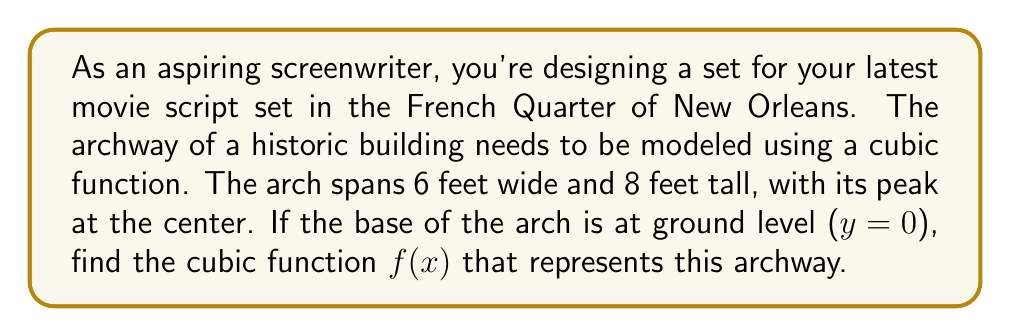Provide a solution to this math problem. Let's approach this step-by-step:

1) The general form of a cubic function is:
   $$f(x) = ax^3 + bx^2 + cx + d$$

2) We know the following points about the arch:
   - It starts at (0, 0)
   - It ends at (6, 0)
   - Its peak is at (3, 8)

3) Let's use these points to set up equations:
   - (0, 0): $f(0) = d = 0$
   - (6, 0): $f(6) = 216a + 36b + 6c + d = 0$
   - (3, 8): $f(3) = 27a + 9b + 3c + d = 8$

4) Since $d = 0$, our function simplifies to:
   $$f(x) = ax^3 + bx^2 + cx$$

5) Now we have two equations:
   $216a + 36b + 6c = 0$  (1)
   $27a + 9b + 3c = 8$    (2)

6) We need one more equation. We can use the fact that the derivative of $f(x)$ at x = 3 should be zero (since it's the peak):
   $$f'(x) = 3ax^2 + 2bx + c$$
   $$f'(3) = 27a + 6b + c = 0$$  (3)

7) Solving these three equations simultaneously:
   From (3): $c = -27a - 6b$
   Substituting into (2): $27a + 9b + 3(-27a - 6b) = 8$
                          $-54a - 9b = 8$
                          $6a + b = -8/9$  (4)

   Substituting $c$ into (1): $216a + 36b + 6(-27a - 6b) = 0$
                               $54a = 0$
                               $a = 0$

   From (4): If $a = 0$, then $b = -8/9$

   And from $c = -27a - 6b$: $c = -6(-8/9) = 16/3$

8) Therefore, our cubic function is:
   $$f(x) = -\frac{8}{9}x^2 + \frac{16}{3}x$$
Answer: $$f(x) = -\frac{8}{9}x^2 + \frac{16}{3}x$$ 